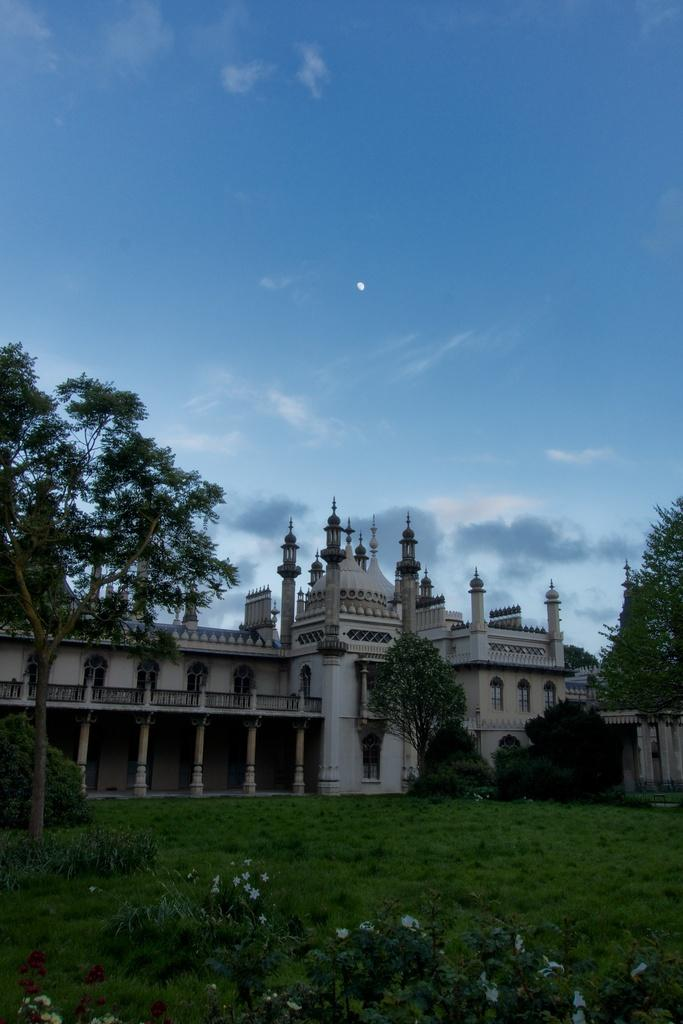What type of vegetation can be seen in the image? There is grass, plants, and trees in the image. What type of structures are visible in the image? There are buildings in the image. What part of the natural environment is visible in the image? The sky is visible in the image, and there are clouds present. What type of education can be seen in the image? There is no reference to education in the image; it features grass, plants, trees, buildings, sky, and clouds. Can you see a rifle in the image? There is no rifle present in the image. 